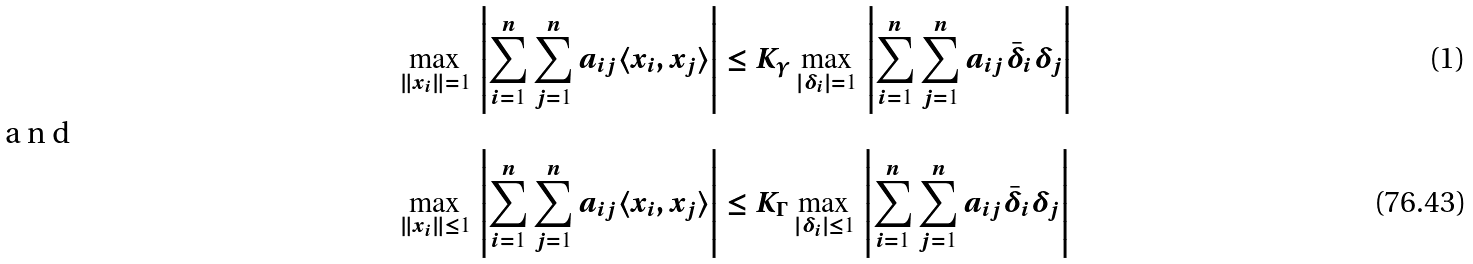Convert formula to latex. <formula><loc_0><loc_0><loc_500><loc_500>\max _ { \| x _ { i } \| = 1 } \, \left | \sum _ { i = 1 } ^ { n } \sum _ { j = 1 } ^ { n } a _ { i j } \langle x _ { i } , x _ { j } \rangle \right | & \leq K _ { \gamma } \max _ { | \delta _ { i } | = 1 } \, \left | \sum _ { i = 1 } ^ { n } \sum _ { j = 1 } ^ { n } a _ { i j } \bar { \delta } _ { i } \delta _ { j } \right | \shortintertext { a n d } \max _ { \| x _ { i } \| \leq 1 } \, \left | \sum _ { i = 1 } ^ { n } \sum _ { j = 1 } ^ { n } a _ { i j } \langle x _ { i } , x _ { j } \rangle \right | & \leq K _ { \Gamma } \max _ { | \delta _ { i } | \leq 1 } \, \left | \sum _ { i = 1 } ^ { n } \sum _ { j = 1 } ^ { n } a _ { i j } \bar { \delta } _ { i } \delta _ { j } \right |</formula> 